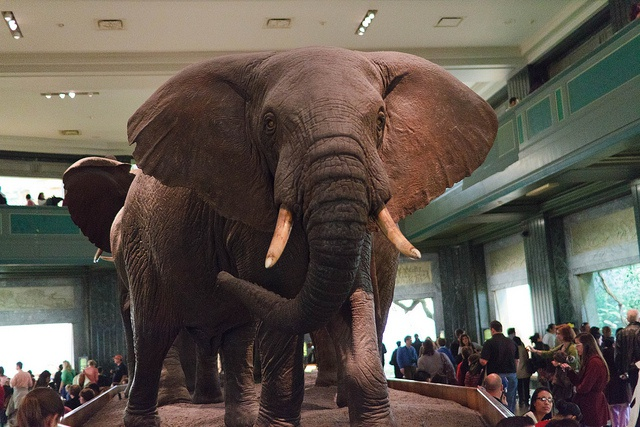Describe the objects in this image and their specific colors. I can see elephant in tan, black, maroon, gray, and brown tones, elephant in tan, black, gray, and maroon tones, people in tan, black, gray, and white tones, people in tan, black, maroon, gray, and brown tones, and people in tan, black, navy, darkblue, and maroon tones in this image. 